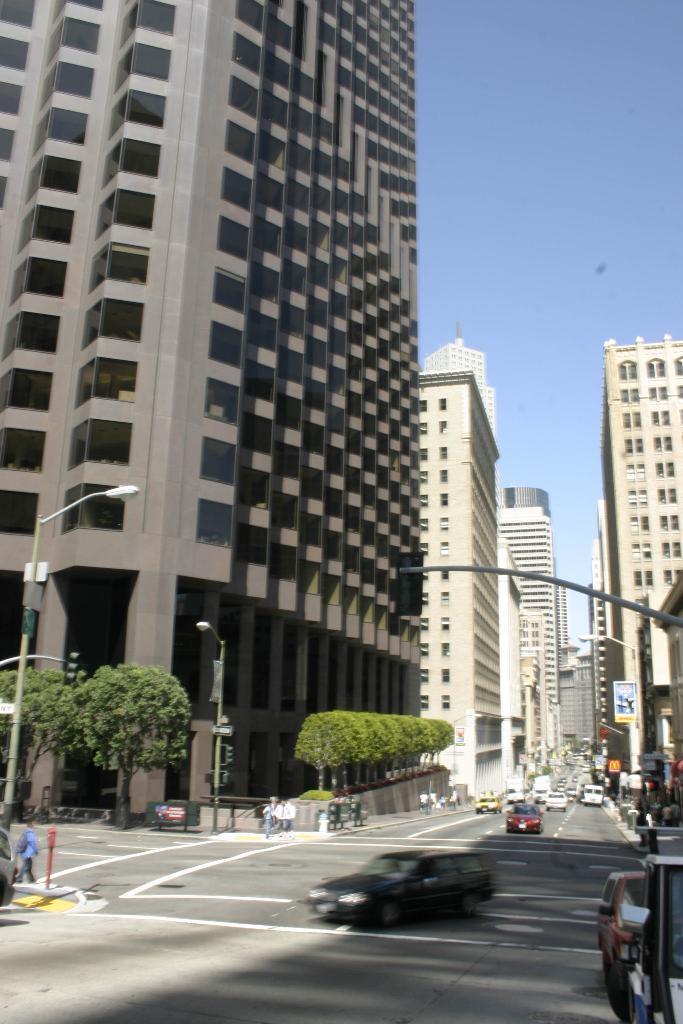Please provide a concise description of this image. In this image there is a road, on that road vehicles are moving, on either side of the road there are buildings,on the left side there are trees and there are pole, in the background there is a sky. 